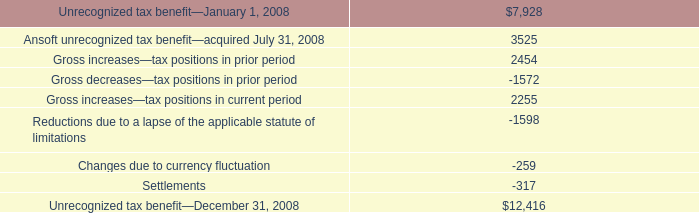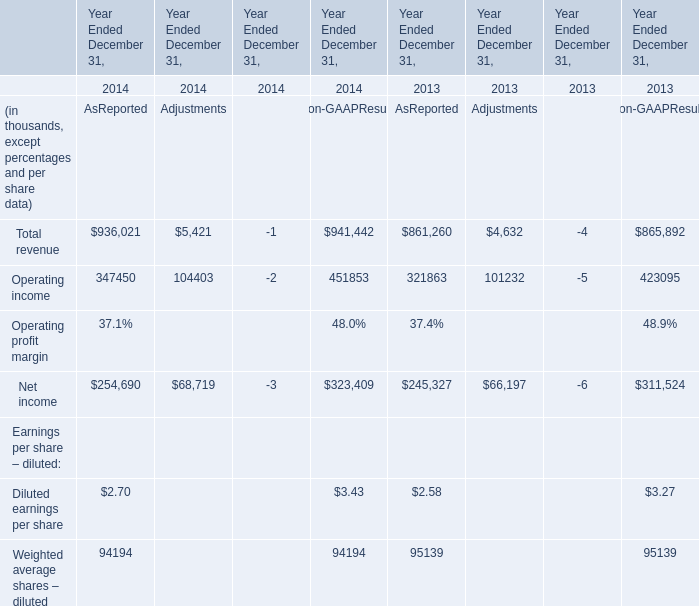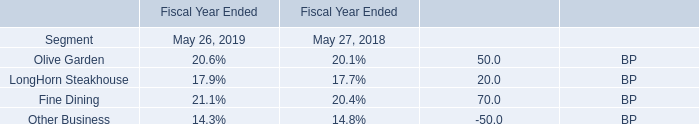What's the growth rate of Total revenue As Reported in 2014? 
Computations: ((936021 - 861260) / 861260)
Answer: 0.0868. 